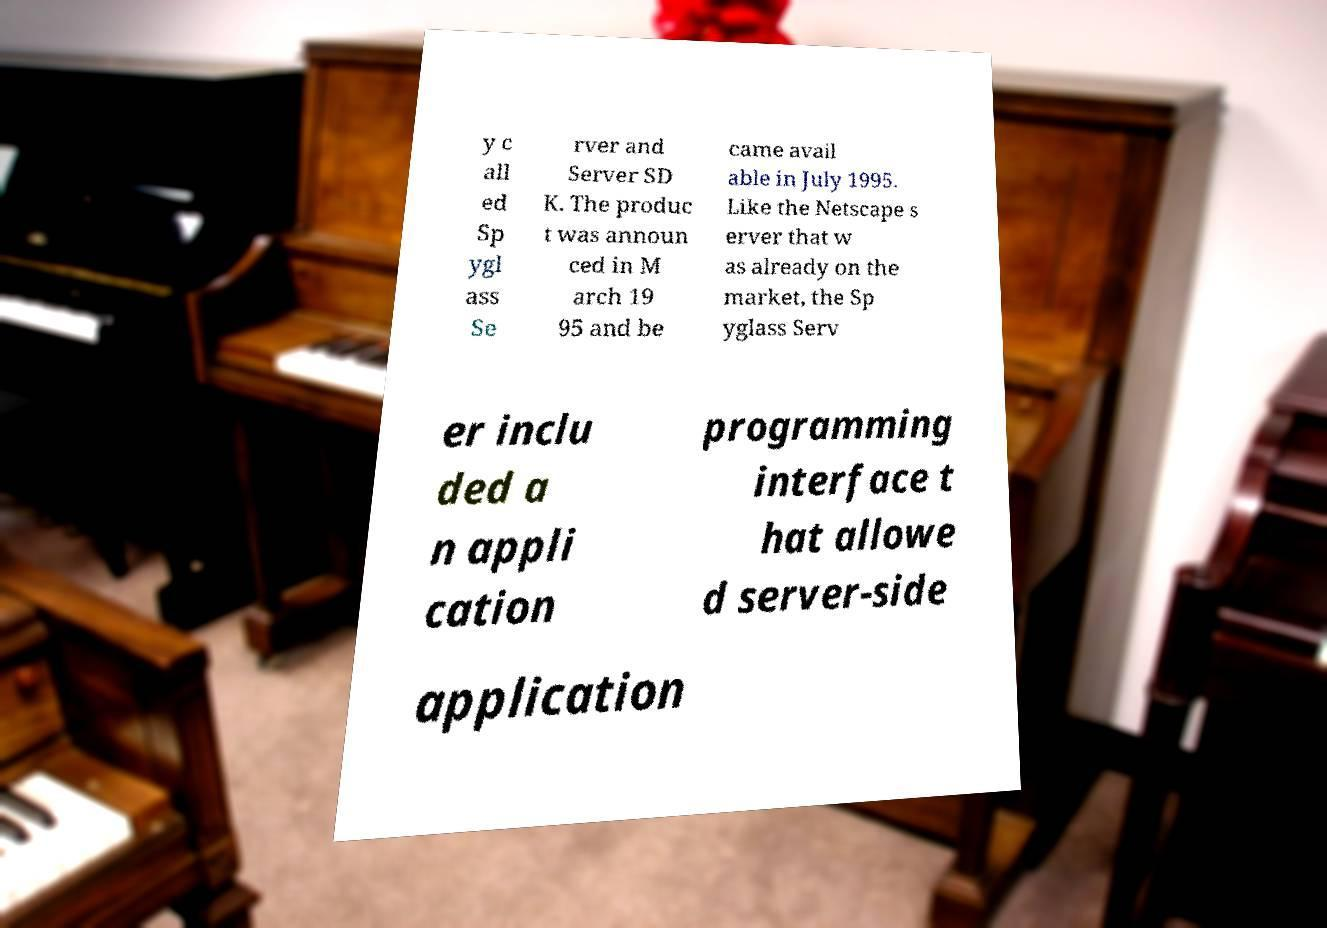For documentation purposes, I need the text within this image transcribed. Could you provide that? y c all ed Sp ygl ass Se rver and Server SD K. The produc t was announ ced in M arch 19 95 and be came avail able in July 1995. Like the Netscape s erver that w as already on the market, the Sp yglass Serv er inclu ded a n appli cation programming interface t hat allowe d server-side application 